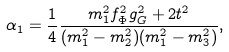<formula> <loc_0><loc_0><loc_500><loc_500>\alpha _ { 1 } = \frac { 1 } { 4 } \frac { m _ { 1 } ^ { 2 } f _ { \Phi } ^ { 2 } g _ { G } ^ { 2 } + 2 t ^ { 2 } } { ( m _ { 1 } ^ { 2 } - m _ { 2 } ^ { 2 } ) ( m _ { 1 } ^ { 2 } - m _ { 3 } ^ { 2 } ) } ,</formula> 